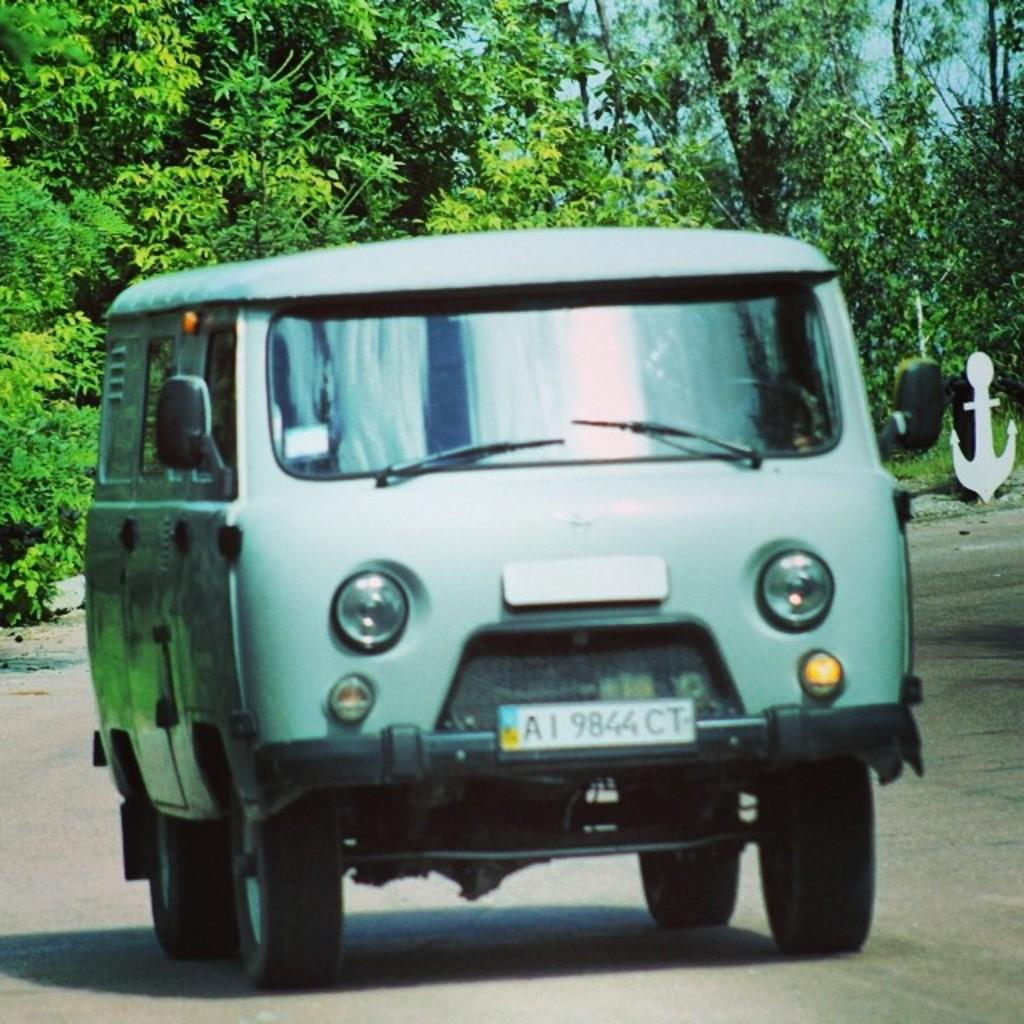What is the main subject of the image? There is a vehicle in the image. What is the vehicle doing in the image? The vehicle is moving on the road. What can be seen in the background of the image? There are trees in the background of the image. What type of alarm can be heard going off in the image? There is no alarm present in the image, and therefore no such sound can be heard. 